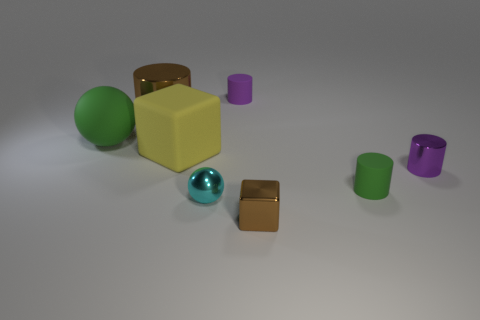Add 1 gray metallic cylinders. How many objects exist? 9 Subtract all balls. How many objects are left? 6 Add 5 metal cylinders. How many metal cylinders are left? 7 Add 6 small brown metal things. How many small brown metal things exist? 7 Subtract 0 green cubes. How many objects are left? 8 Subtract all big blue metallic cubes. Subtract all big cylinders. How many objects are left? 7 